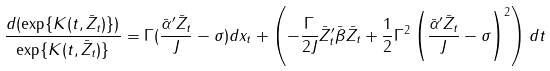<formula> <loc_0><loc_0><loc_500><loc_500>\frac { d ( \exp \{ K ( t , \bar { Z } _ { t } ) \} ) } { \exp \{ K ( t , \bar { Z } _ { t } ) \} } = \Gamma ( \frac { \bar { \alpha } ^ { \prime } \bar { Z } _ { t } } { J } - \sigma ) d x _ { t } + \left ( - \frac { \Gamma } { 2 J } \bar { Z } _ { t } ^ { \prime } \bar { \beta } \bar { Z _ { t } } + \frac { 1 } { 2 } \Gamma ^ { 2 } \left ( \frac { \bar { \alpha } ^ { \prime } \bar { Z } _ { t } } { J } - \sigma \right ) ^ { 2 } \right ) d t</formula> 